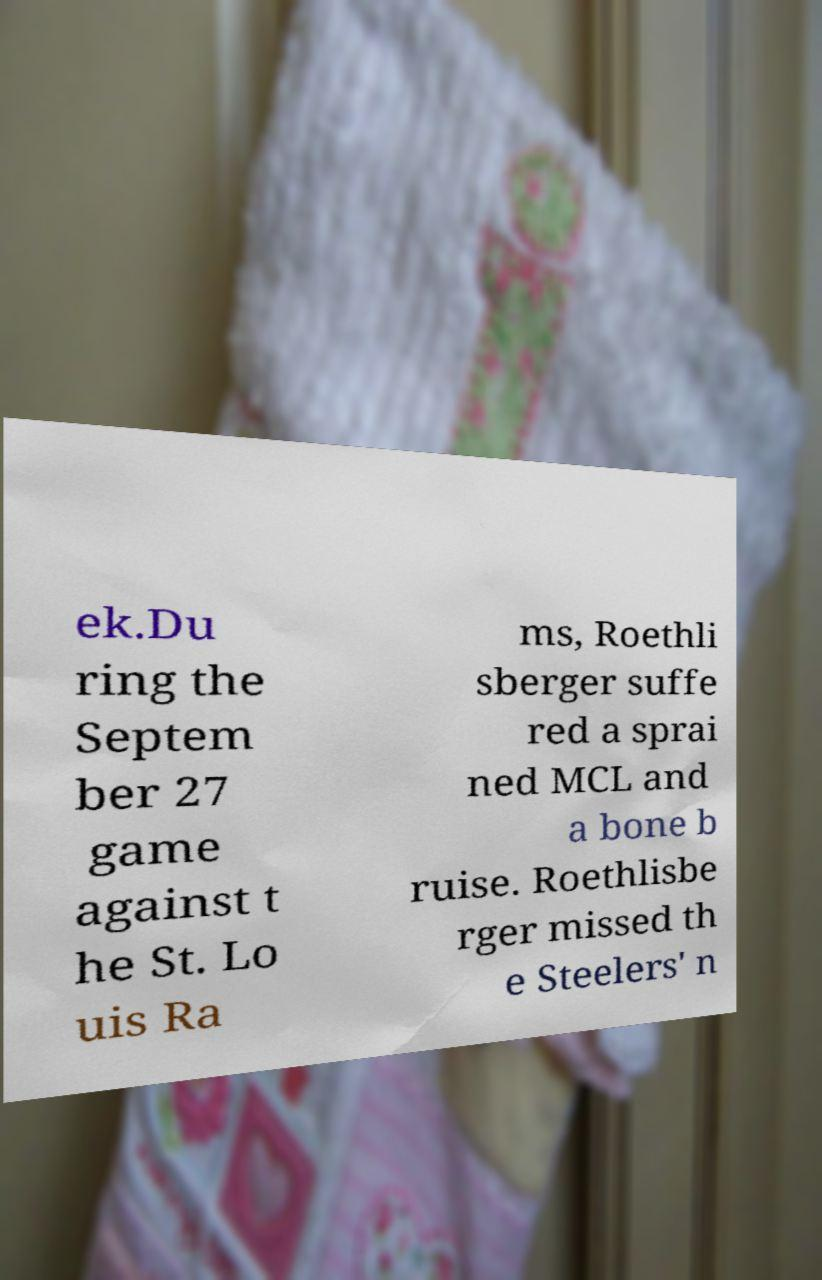I need the written content from this picture converted into text. Can you do that? ek.Du ring the Septem ber 27 game against t he St. Lo uis Ra ms, Roethli sberger suffe red a sprai ned MCL and a bone b ruise. Roethlisbe rger missed th e Steelers' n 